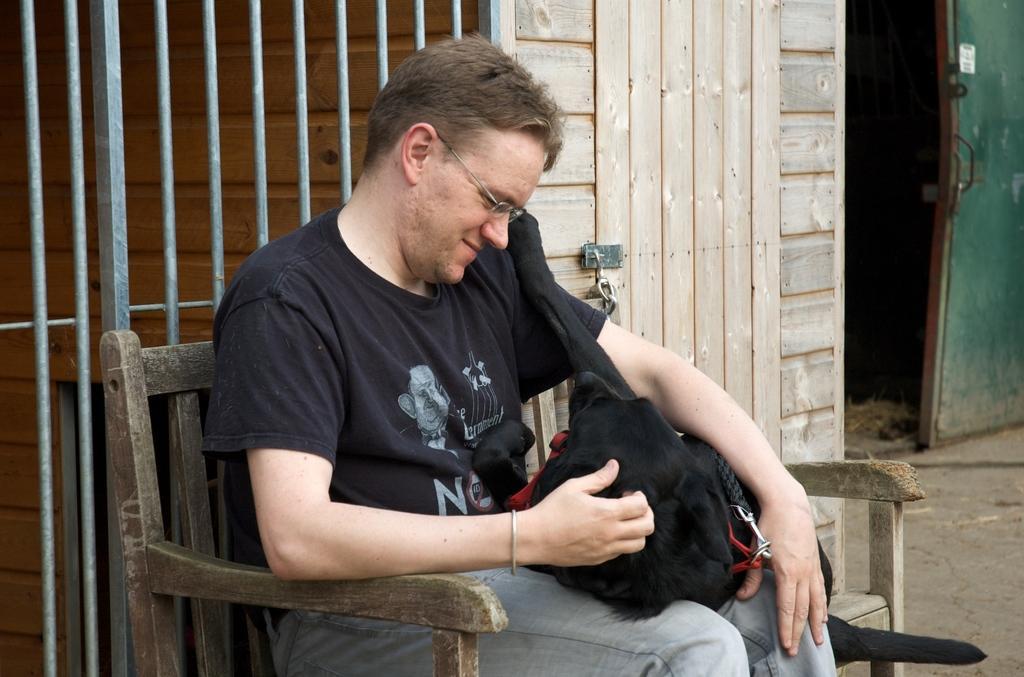Please provide a concise description of this image. In the image there is a wooden chair,on the chair a man is sitting he is holding a dog of black color,the background is a door with some rods,beside that there is a wooden house there is a lock to the door,to the right side there is a green color door. 